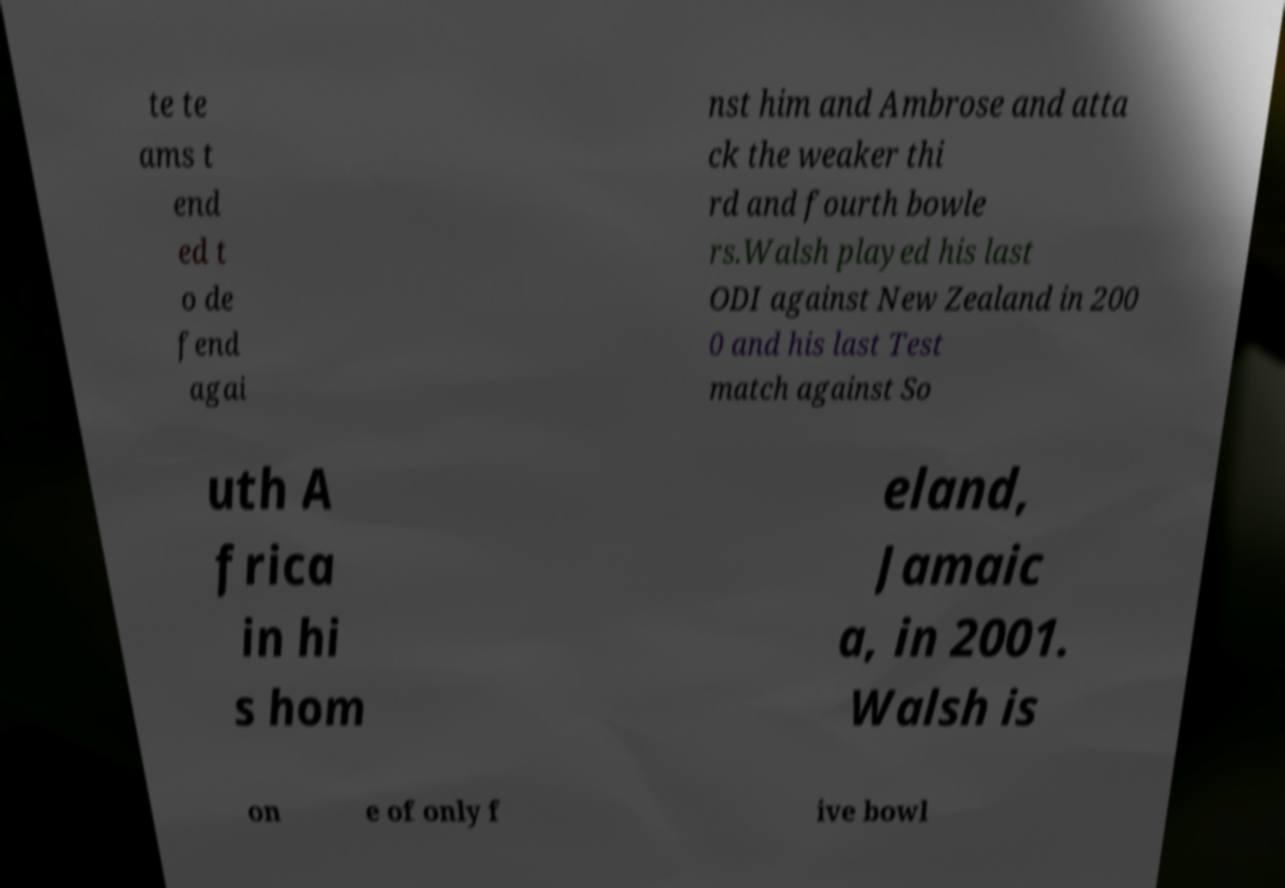Can you read and provide the text displayed in the image?This photo seems to have some interesting text. Can you extract and type it out for me? te te ams t end ed t o de fend agai nst him and Ambrose and atta ck the weaker thi rd and fourth bowle rs.Walsh played his last ODI against New Zealand in 200 0 and his last Test match against So uth A frica in hi s hom eland, Jamaic a, in 2001. Walsh is on e of only f ive bowl 